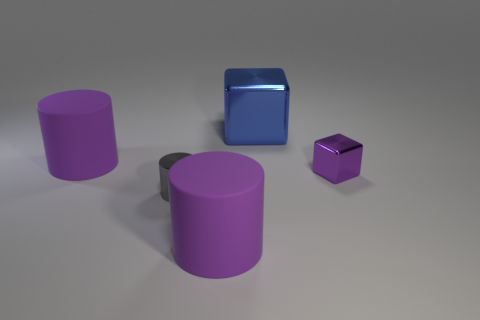Subtract all large purple cylinders. How many cylinders are left? 1 Add 2 blue things. How many objects exist? 7 Subtract all blocks. How many objects are left? 3 Add 5 purple shiny objects. How many purple shiny objects are left? 6 Add 5 purple shiny cylinders. How many purple shiny cylinders exist? 5 Subtract 0 yellow balls. How many objects are left? 5 Subtract all tiny metallic cubes. Subtract all big shiny objects. How many objects are left? 3 